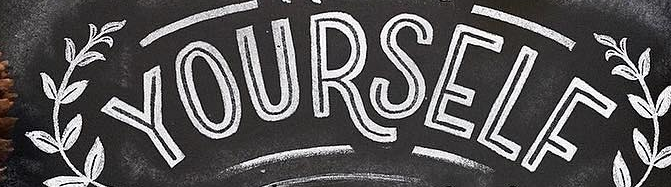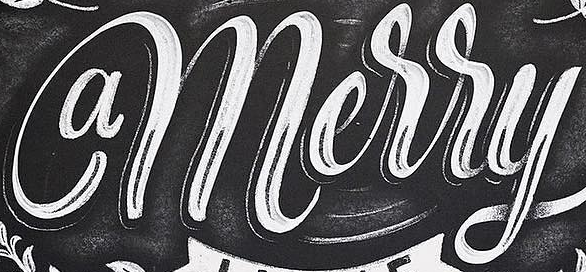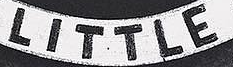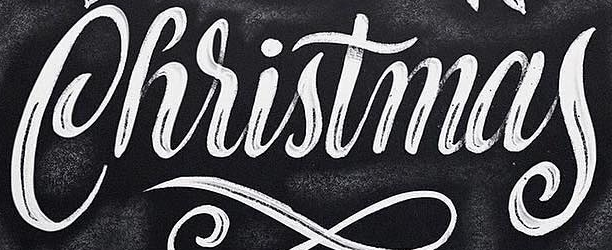What words are shown in these images in order, separated by a semicolon? YOURSELF; amerry; LITTLE; Christmas 